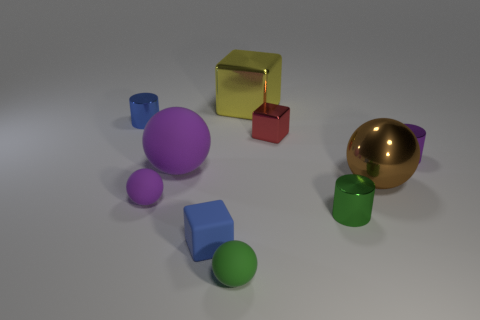There is a small cylinder that is the same color as the matte block; what material is it?
Your answer should be compact. Metal. What is the size of the blue block that is the same material as the small purple ball?
Provide a succinct answer. Small. There is a tiny matte thing that is the same color as the large matte sphere; what is its shape?
Make the answer very short. Sphere. There is a tiny purple object on the right side of the object behind the blue metallic cylinder; what is its material?
Offer a terse response. Metal. What size is the cylinder on the left side of the small green thing in front of the cube that is in front of the small shiny block?
Provide a short and direct response. Small. How many other things are there of the same shape as the tiny red thing?
Provide a succinct answer. 2. Is the color of the tiny matte ball that is in front of the small green cylinder the same as the small matte thing on the left side of the small rubber cube?
Provide a succinct answer. No. What color is the sphere that is the same size as the green rubber thing?
Give a very brief answer. Purple. Are there any small metal cylinders that have the same color as the tiny rubber block?
Make the answer very short. Yes. Does the green object on the left side of the green metal object have the same size as the tiny metallic block?
Ensure brevity in your answer.  Yes. 